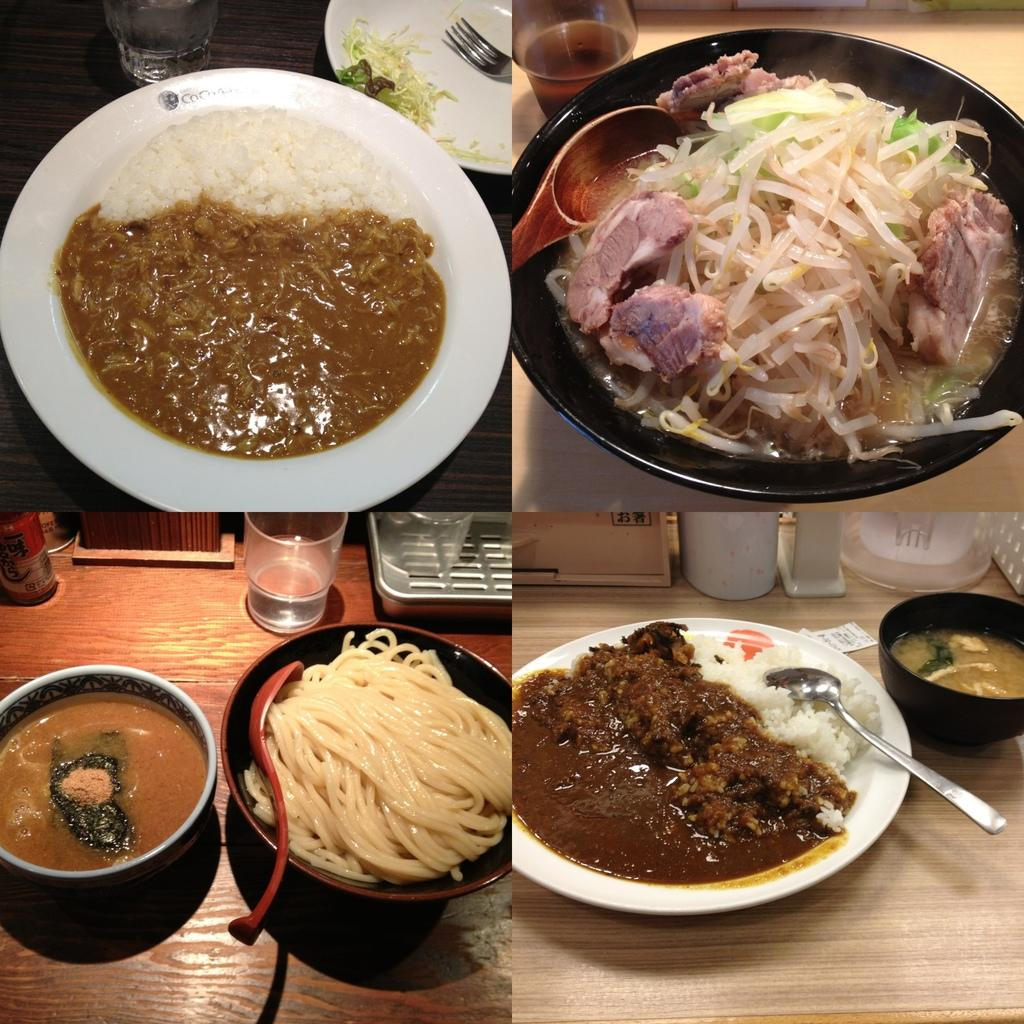What type of photographs are in the image? There are college photographs of food in the image. What color is the plate that the food is on? The food is on a white color plate. What material is the surface that the plate is placed on? The plate is placed on a wooden table top. What type of jewel is placed on top of the pancakes in the image? There are no pancakes or jewels present in the image; it features college photographs of food on a white plate placed on a wooden table top. 